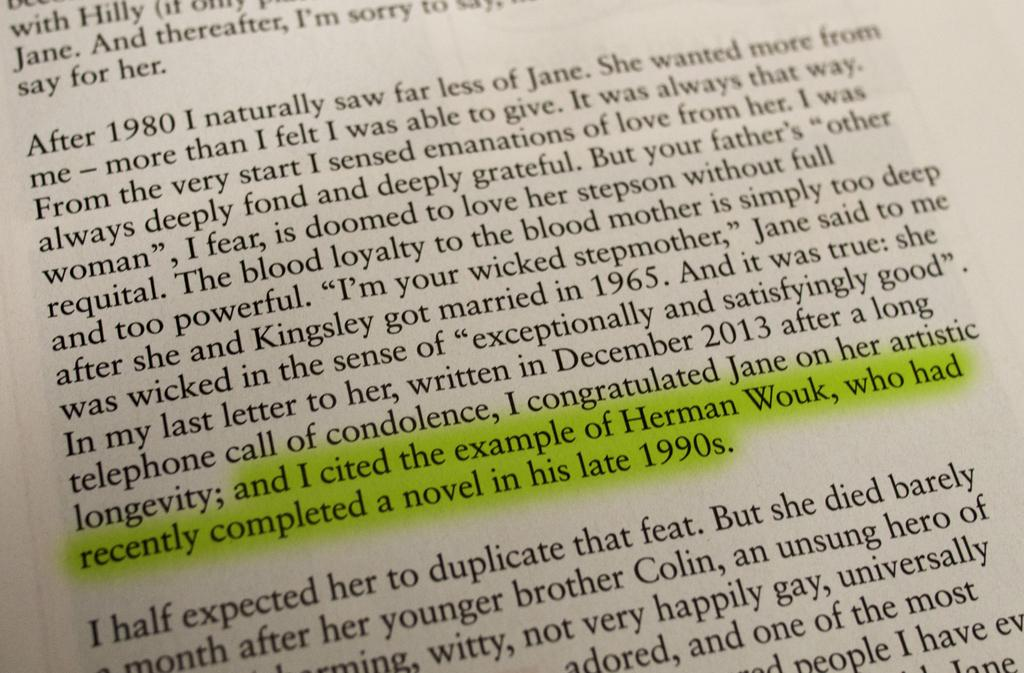<image>
Describe the image concisely. A page of writing with some of the words highlighted and I cited the example of Herman Wouk. 